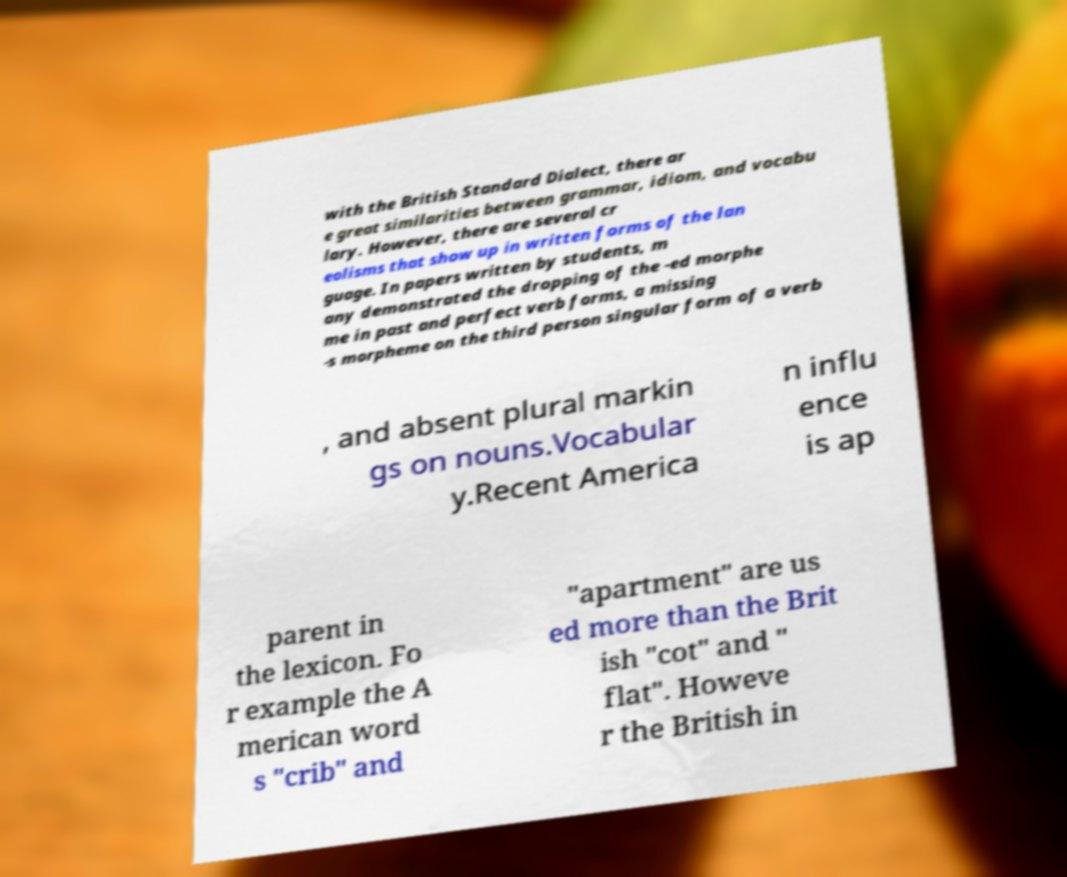Please identify and transcribe the text found in this image. with the British Standard Dialect, there ar e great similarities between grammar, idiom, and vocabu lary. However, there are several cr eolisms that show up in written forms of the lan guage. In papers written by students, m any demonstrated the dropping of the -ed morphe me in past and perfect verb forms, a missing -s morpheme on the third person singular form of a verb , and absent plural markin gs on nouns.Vocabular y.Recent America n influ ence is ap parent in the lexicon. Fo r example the A merican word s "crib" and "apartment" are us ed more than the Brit ish "cot" and " flat". Howeve r the British in 